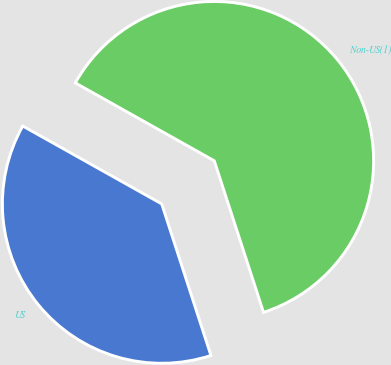Convert chart to OTSL. <chart><loc_0><loc_0><loc_500><loc_500><pie_chart><fcel>US<fcel>Non-US(1)<nl><fcel>38.13%<fcel>61.87%<nl></chart> 